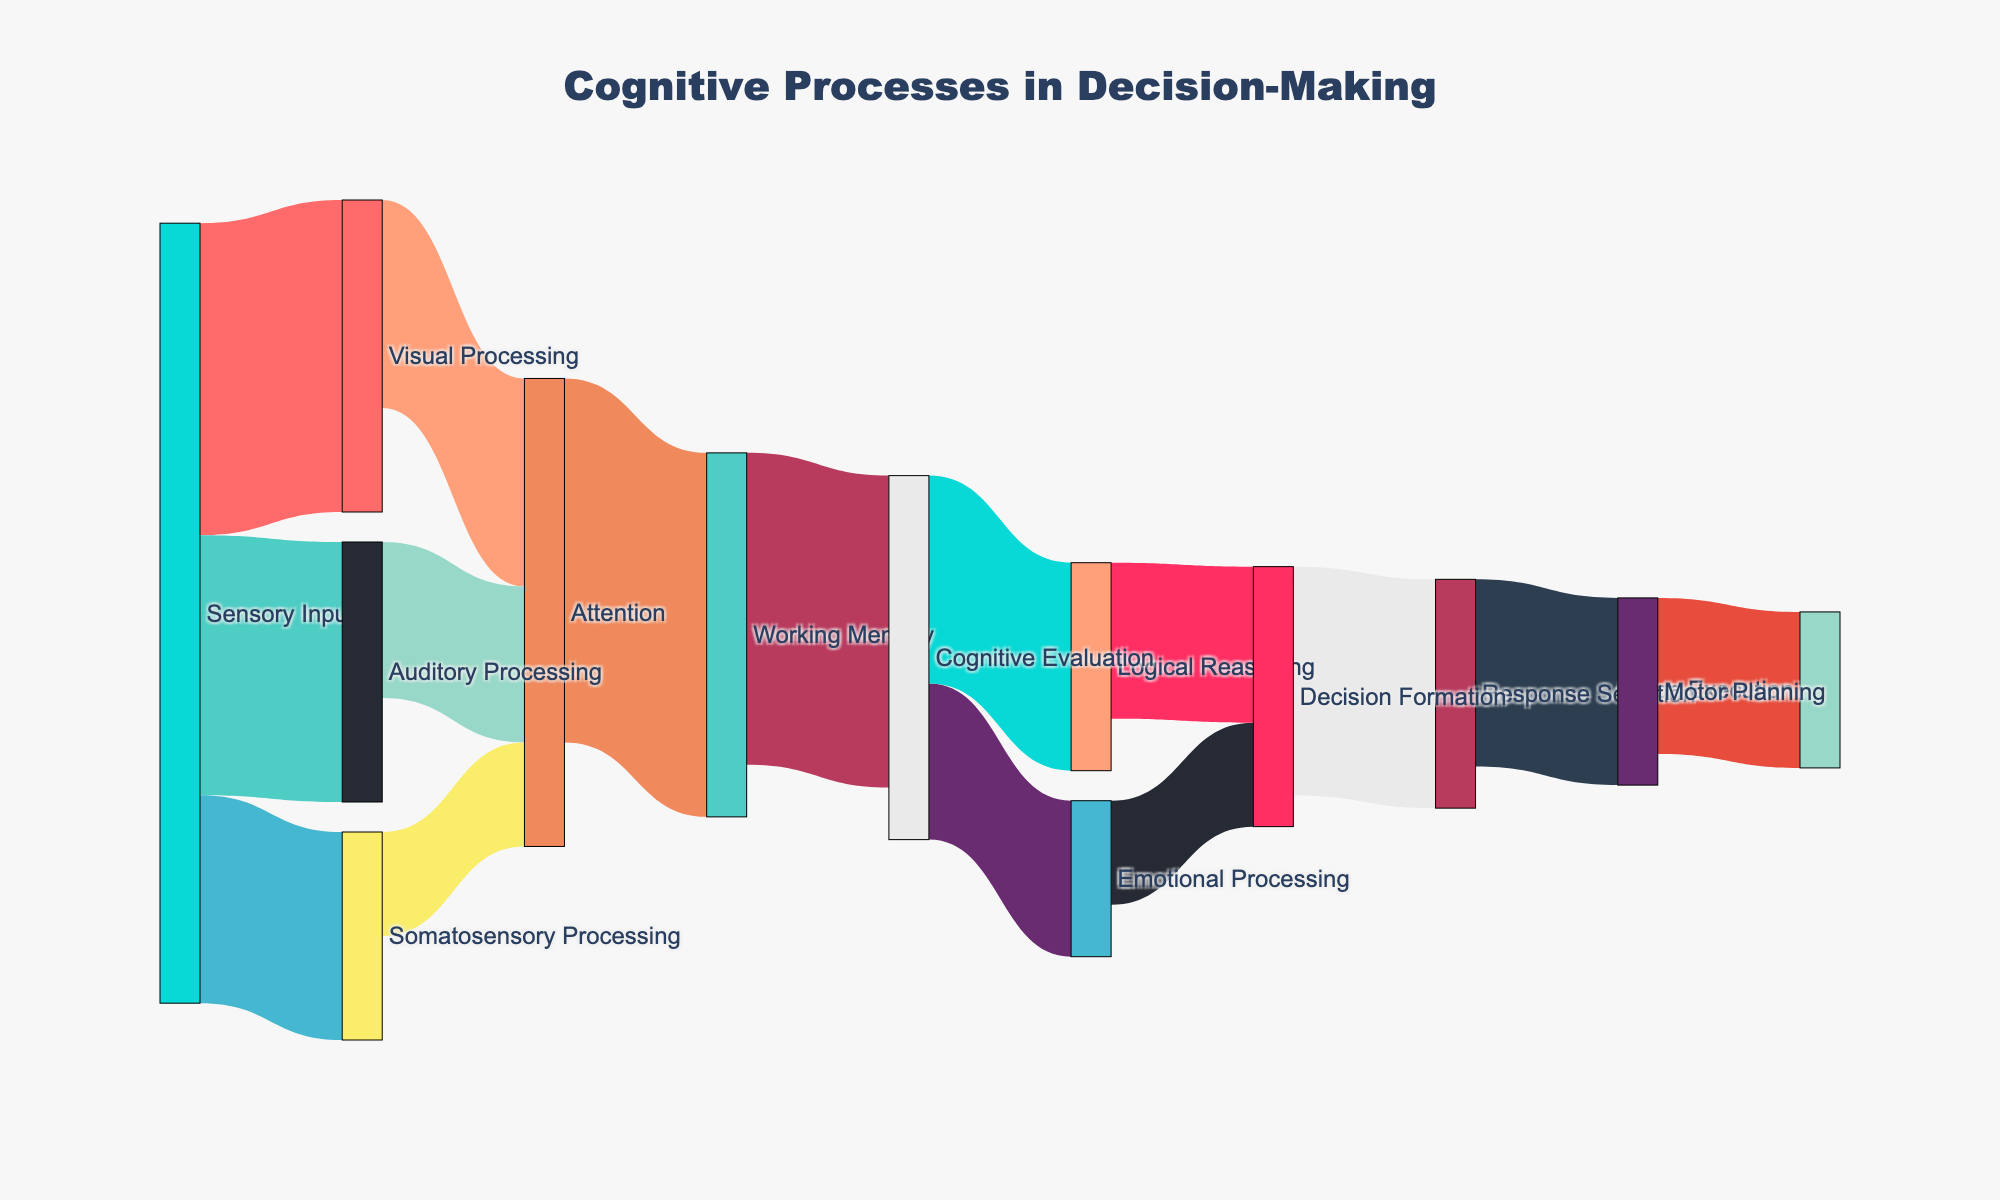what is the title of the figure? The title is displayed at the top of the figure. It is "Cognitive Processes in Decision-Making."
Answer: Cognitive Processes in Decision-Making How many types of sensory processing are shown in the figure? The figure shows three different types of sensory processing as the initial nodes connected to Sensory Input: Visual Processing, Auditory Processing, and Somatosensory Processing.
Answer: Three Which cognitive process has the highest value for working memory input? Attention connects to Working Memory with a value indicated by the thickness of the link. It has a value of 35.
Answer: Attention What is the total value flowing into cognitive evaluation? To find this, look at the links targeting Cognitive Evaluation: one from Working Memory, with a value of 30. Thus, the total value is 30.
Answer: 30 What is the difference in value between visual processing and somatosensory processing for attention? The value from Visual Processing to Attention is 20, and from Somatosensory Processing to Attention is 10. The difference is 20 - 10.
Answer: 10 Compare the values of Emotional Processing and Logical Reasoning inflows into Decision Formation. Which one is higher? Emotional Processing flows into Decision Formation with a value of 10 while Logical Reasoning flows into Decision Formation with a value of 15. Logical Reasoning has the higher value.
Answer: Logical Reasoning What is the combined value of Sensory Input process across Visual, Auditory, and Somatosensory Processing? The values are 30 for Visual, 25 for Auditory, and 20 for Somatosensory. Summing these values gives 30 + 25 + 20.
Answer: 75 Trace the flow starting from Working Memory to Action Execution. What is the total value of this path? The path is: Working Memory (30) -> Cognitive Evaluation (30) -> Decision Formation (sum of 15 from Logical Reasoning and 10 from Emotional Processing = 25) -> Response Selection (22) -> Motor Planning (18) -> Action Execution (15). Since we follow the singular high-value flow in each step, the core path is 30(non-interruption)->25(Decision Formation)->22(Response Selection)->18(Motor Planning)->15.
Answer: 15 Which process contributes more to Response Selection, Decision Formation or Attention? Decision Formation contributes directly to Response Selection with a value of 22, while Attention's contribution is indirect and lesser value-wise.
Answer: Decision Formation 